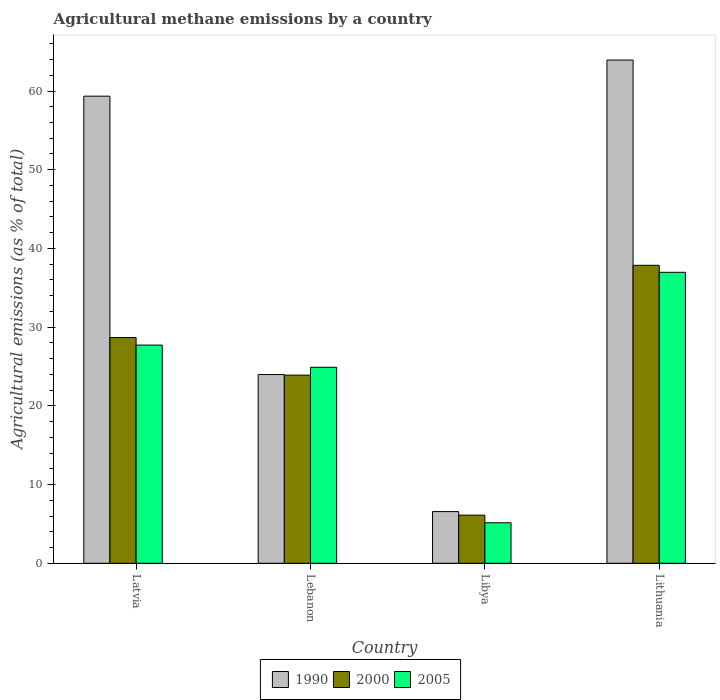How many bars are there on the 2nd tick from the left?
Give a very brief answer. 3. What is the label of the 3rd group of bars from the left?
Offer a very short reply. Libya. What is the amount of agricultural methane emitted in 1990 in Lithuania?
Your answer should be very brief. 63.93. Across all countries, what is the maximum amount of agricultural methane emitted in 2005?
Ensure brevity in your answer.  36.97. Across all countries, what is the minimum amount of agricultural methane emitted in 2000?
Offer a very short reply. 6.12. In which country was the amount of agricultural methane emitted in 2005 maximum?
Your answer should be compact. Lithuania. In which country was the amount of agricultural methane emitted in 2000 minimum?
Your response must be concise. Libya. What is the total amount of agricultural methane emitted in 2005 in the graph?
Provide a succinct answer. 94.74. What is the difference between the amount of agricultural methane emitted in 2000 in Latvia and that in Libya?
Your answer should be compact. 22.56. What is the difference between the amount of agricultural methane emitted in 2005 in Libya and the amount of agricultural methane emitted in 1990 in Lithuania?
Your answer should be compact. -58.79. What is the average amount of agricultural methane emitted in 2005 per country?
Offer a very short reply. 23.68. What is the difference between the amount of agricultural methane emitted of/in 2005 and amount of agricultural methane emitted of/in 2000 in Lebanon?
Offer a terse response. 1. What is the ratio of the amount of agricultural methane emitted in 2000 in Latvia to that in Lebanon?
Ensure brevity in your answer.  1.2. Is the amount of agricultural methane emitted in 2005 in Libya less than that in Lithuania?
Offer a terse response. Yes. What is the difference between the highest and the second highest amount of agricultural methane emitted in 2000?
Give a very brief answer. -9.18. What is the difference between the highest and the lowest amount of agricultural methane emitted in 2000?
Provide a succinct answer. 31.74. In how many countries, is the amount of agricultural methane emitted in 2005 greater than the average amount of agricultural methane emitted in 2005 taken over all countries?
Your answer should be very brief. 3. Is the sum of the amount of agricultural methane emitted in 2000 in Latvia and Lithuania greater than the maximum amount of agricultural methane emitted in 1990 across all countries?
Make the answer very short. Yes. Is it the case that in every country, the sum of the amount of agricultural methane emitted in 1990 and amount of agricultural methane emitted in 2000 is greater than the amount of agricultural methane emitted in 2005?
Provide a succinct answer. Yes. Are all the bars in the graph horizontal?
Your answer should be compact. No. How many countries are there in the graph?
Keep it short and to the point. 4. Does the graph contain any zero values?
Provide a short and direct response. No. Where does the legend appear in the graph?
Keep it short and to the point. Bottom center. How many legend labels are there?
Give a very brief answer. 3. What is the title of the graph?
Your response must be concise. Agricultural methane emissions by a country. Does "2014" appear as one of the legend labels in the graph?
Keep it short and to the point. No. What is the label or title of the X-axis?
Offer a very short reply. Country. What is the label or title of the Y-axis?
Ensure brevity in your answer.  Agricultural emissions (as % of total). What is the Agricultural emissions (as % of total) in 1990 in Latvia?
Ensure brevity in your answer.  59.34. What is the Agricultural emissions (as % of total) in 2000 in Latvia?
Provide a succinct answer. 28.68. What is the Agricultural emissions (as % of total) of 2005 in Latvia?
Offer a very short reply. 27.72. What is the Agricultural emissions (as % of total) in 1990 in Lebanon?
Offer a very short reply. 23.98. What is the Agricultural emissions (as % of total) in 2000 in Lebanon?
Your response must be concise. 23.9. What is the Agricultural emissions (as % of total) of 2005 in Lebanon?
Offer a very short reply. 24.9. What is the Agricultural emissions (as % of total) in 1990 in Libya?
Provide a succinct answer. 6.57. What is the Agricultural emissions (as % of total) of 2000 in Libya?
Provide a short and direct response. 6.12. What is the Agricultural emissions (as % of total) in 2005 in Libya?
Make the answer very short. 5.15. What is the Agricultural emissions (as % of total) in 1990 in Lithuania?
Your answer should be very brief. 63.93. What is the Agricultural emissions (as % of total) of 2000 in Lithuania?
Give a very brief answer. 37.86. What is the Agricultural emissions (as % of total) in 2005 in Lithuania?
Your response must be concise. 36.97. Across all countries, what is the maximum Agricultural emissions (as % of total) of 1990?
Give a very brief answer. 63.93. Across all countries, what is the maximum Agricultural emissions (as % of total) in 2000?
Ensure brevity in your answer.  37.86. Across all countries, what is the maximum Agricultural emissions (as % of total) of 2005?
Offer a very short reply. 36.97. Across all countries, what is the minimum Agricultural emissions (as % of total) in 1990?
Ensure brevity in your answer.  6.57. Across all countries, what is the minimum Agricultural emissions (as % of total) of 2000?
Provide a succinct answer. 6.12. Across all countries, what is the minimum Agricultural emissions (as % of total) of 2005?
Your response must be concise. 5.15. What is the total Agricultural emissions (as % of total) in 1990 in the graph?
Keep it short and to the point. 153.82. What is the total Agricultural emissions (as % of total) of 2000 in the graph?
Provide a succinct answer. 96.55. What is the total Agricultural emissions (as % of total) of 2005 in the graph?
Keep it short and to the point. 94.74. What is the difference between the Agricultural emissions (as % of total) of 1990 in Latvia and that in Lebanon?
Offer a very short reply. 35.37. What is the difference between the Agricultural emissions (as % of total) in 2000 in Latvia and that in Lebanon?
Ensure brevity in your answer.  4.78. What is the difference between the Agricultural emissions (as % of total) in 2005 in Latvia and that in Lebanon?
Your answer should be compact. 2.82. What is the difference between the Agricultural emissions (as % of total) of 1990 in Latvia and that in Libya?
Keep it short and to the point. 52.78. What is the difference between the Agricultural emissions (as % of total) in 2000 in Latvia and that in Libya?
Your response must be concise. 22.56. What is the difference between the Agricultural emissions (as % of total) of 2005 in Latvia and that in Libya?
Your response must be concise. 22.57. What is the difference between the Agricultural emissions (as % of total) of 1990 in Latvia and that in Lithuania?
Offer a very short reply. -4.59. What is the difference between the Agricultural emissions (as % of total) of 2000 in Latvia and that in Lithuania?
Offer a very short reply. -9.18. What is the difference between the Agricultural emissions (as % of total) in 2005 in Latvia and that in Lithuania?
Your response must be concise. -9.25. What is the difference between the Agricultural emissions (as % of total) of 1990 in Lebanon and that in Libya?
Provide a succinct answer. 17.41. What is the difference between the Agricultural emissions (as % of total) in 2000 in Lebanon and that in Libya?
Offer a very short reply. 17.79. What is the difference between the Agricultural emissions (as % of total) in 2005 in Lebanon and that in Libya?
Your answer should be very brief. 19.76. What is the difference between the Agricultural emissions (as % of total) in 1990 in Lebanon and that in Lithuania?
Make the answer very short. -39.96. What is the difference between the Agricultural emissions (as % of total) of 2000 in Lebanon and that in Lithuania?
Ensure brevity in your answer.  -13.95. What is the difference between the Agricultural emissions (as % of total) of 2005 in Lebanon and that in Lithuania?
Give a very brief answer. -12.07. What is the difference between the Agricultural emissions (as % of total) of 1990 in Libya and that in Lithuania?
Offer a very short reply. -57.37. What is the difference between the Agricultural emissions (as % of total) of 2000 in Libya and that in Lithuania?
Your answer should be very brief. -31.74. What is the difference between the Agricultural emissions (as % of total) of 2005 in Libya and that in Lithuania?
Make the answer very short. -31.82. What is the difference between the Agricultural emissions (as % of total) of 1990 in Latvia and the Agricultural emissions (as % of total) of 2000 in Lebanon?
Provide a short and direct response. 35.44. What is the difference between the Agricultural emissions (as % of total) of 1990 in Latvia and the Agricultural emissions (as % of total) of 2005 in Lebanon?
Your answer should be compact. 34.44. What is the difference between the Agricultural emissions (as % of total) of 2000 in Latvia and the Agricultural emissions (as % of total) of 2005 in Lebanon?
Make the answer very short. 3.78. What is the difference between the Agricultural emissions (as % of total) of 1990 in Latvia and the Agricultural emissions (as % of total) of 2000 in Libya?
Provide a succinct answer. 53.23. What is the difference between the Agricultural emissions (as % of total) in 1990 in Latvia and the Agricultural emissions (as % of total) in 2005 in Libya?
Keep it short and to the point. 54.2. What is the difference between the Agricultural emissions (as % of total) of 2000 in Latvia and the Agricultural emissions (as % of total) of 2005 in Libya?
Your answer should be compact. 23.53. What is the difference between the Agricultural emissions (as % of total) in 1990 in Latvia and the Agricultural emissions (as % of total) in 2000 in Lithuania?
Keep it short and to the point. 21.49. What is the difference between the Agricultural emissions (as % of total) of 1990 in Latvia and the Agricultural emissions (as % of total) of 2005 in Lithuania?
Offer a very short reply. 22.38. What is the difference between the Agricultural emissions (as % of total) of 2000 in Latvia and the Agricultural emissions (as % of total) of 2005 in Lithuania?
Your answer should be compact. -8.29. What is the difference between the Agricultural emissions (as % of total) in 1990 in Lebanon and the Agricultural emissions (as % of total) in 2000 in Libya?
Offer a terse response. 17.86. What is the difference between the Agricultural emissions (as % of total) of 1990 in Lebanon and the Agricultural emissions (as % of total) of 2005 in Libya?
Make the answer very short. 18.83. What is the difference between the Agricultural emissions (as % of total) in 2000 in Lebanon and the Agricultural emissions (as % of total) in 2005 in Libya?
Give a very brief answer. 18.76. What is the difference between the Agricultural emissions (as % of total) in 1990 in Lebanon and the Agricultural emissions (as % of total) in 2000 in Lithuania?
Keep it short and to the point. -13.88. What is the difference between the Agricultural emissions (as % of total) in 1990 in Lebanon and the Agricultural emissions (as % of total) in 2005 in Lithuania?
Keep it short and to the point. -12.99. What is the difference between the Agricultural emissions (as % of total) in 2000 in Lebanon and the Agricultural emissions (as % of total) in 2005 in Lithuania?
Your answer should be very brief. -13.07. What is the difference between the Agricultural emissions (as % of total) in 1990 in Libya and the Agricultural emissions (as % of total) in 2000 in Lithuania?
Your response must be concise. -31.29. What is the difference between the Agricultural emissions (as % of total) of 1990 in Libya and the Agricultural emissions (as % of total) of 2005 in Lithuania?
Your answer should be compact. -30.4. What is the difference between the Agricultural emissions (as % of total) in 2000 in Libya and the Agricultural emissions (as % of total) in 2005 in Lithuania?
Provide a succinct answer. -30.85. What is the average Agricultural emissions (as % of total) of 1990 per country?
Your answer should be very brief. 38.46. What is the average Agricultural emissions (as % of total) of 2000 per country?
Provide a succinct answer. 24.14. What is the average Agricultural emissions (as % of total) in 2005 per country?
Provide a short and direct response. 23.68. What is the difference between the Agricultural emissions (as % of total) of 1990 and Agricultural emissions (as % of total) of 2000 in Latvia?
Provide a succinct answer. 30.66. What is the difference between the Agricultural emissions (as % of total) of 1990 and Agricultural emissions (as % of total) of 2005 in Latvia?
Ensure brevity in your answer.  31.62. What is the difference between the Agricultural emissions (as % of total) in 2000 and Agricultural emissions (as % of total) in 2005 in Latvia?
Offer a terse response. 0.96. What is the difference between the Agricultural emissions (as % of total) of 1990 and Agricultural emissions (as % of total) of 2000 in Lebanon?
Ensure brevity in your answer.  0.07. What is the difference between the Agricultural emissions (as % of total) in 1990 and Agricultural emissions (as % of total) in 2005 in Lebanon?
Make the answer very short. -0.93. What is the difference between the Agricultural emissions (as % of total) of 2000 and Agricultural emissions (as % of total) of 2005 in Lebanon?
Provide a succinct answer. -1. What is the difference between the Agricultural emissions (as % of total) in 1990 and Agricultural emissions (as % of total) in 2000 in Libya?
Provide a short and direct response. 0.45. What is the difference between the Agricultural emissions (as % of total) in 1990 and Agricultural emissions (as % of total) in 2005 in Libya?
Keep it short and to the point. 1.42. What is the difference between the Agricultural emissions (as % of total) in 2000 and Agricultural emissions (as % of total) in 2005 in Libya?
Your answer should be compact. 0.97. What is the difference between the Agricultural emissions (as % of total) in 1990 and Agricultural emissions (as % of total) in 2000 in Lithuania?
Provide a short and direct response. 26.08. What is the difference between the Agricultural emissions (as % of total) of 1990 and Agricultural emissions (as % of total) of 2005 in Lithuania?
Your answer should be compact. 26.97. What is the difference between the Agricultural emissions (as % of total) in 2000 and Agricultural emissions (as % of total) in 2005 in Lithuania?
Make the answer very short. 0.89. What is the ratio of the Agricultural emissions (as % of total) in 1990 in Latvia to that in Lebanon?
Your answer should be compact. 2.48. What is the ratio of the Agricultural emissions (as % of total) in 2000 in Latvia to that in Lebanon?
Ensure brevity in your answer.  1.2. What is the ratio of the Agricultural emissions (as % of total) of 2005 in Latvia to that in Lebanon?
Provide a short and direct response. 1.11. What is the ratio of the Agricultural emissions (as % of total) in 1990 in Latvia to that in Libya?
Provide a short and direct response. 9.04. What is the ratio of the Agricultural emissions (as % of total) of 2000 in Latvia to that in Libya?
Offer a very short reply. 4.69. What is the ratio of the Agricultural emissions (as % of total) in 2005 in Latvia to that in Libya?
Offer a terse response. 5.39. What is the ratio of the Agricultural emissions (as % of total) in 1990 in Latvia to that in Lithuania?
Your answer should be compact. 0.93. What is the ratio of the Agricultural emissions (as % of total) in 2000 in Latvia to that in Lithuania?
Your answer should be very brief. 0.76. What is the ratio of the Agricultural emissions (as % of total) of 2005 in Latvia to that in Lithuania?
Your answer should be compact. 0.75. What is the ratio of the Agricultural emissions (as % of total) in 1990 in Lebanon to that in Libya?
Your answer should be compact. 3.65. What is the ratio of the Agricultural emissions (as % of total) of 2000 in Lebanon to that in Libya?
Provide a succinct answer. 3.91. What is the ratio of the Agricultural emissions (as % of total) of 2005 in Lebanon to that in Libya?
Make the answer very short. 4.84. What is the ratio of the Agricultural emissions (as % of total) of 2000 in Lebanon to that in Lithuania?
Ensure brevity in your answer.  0.63. What is the ratio of the Agricultural emissions (as % of total) of 2005 in Lebanon to that in Lithuania?
Provide a short and direct response. 0.67. What is the ratio of the Agricultural emissions (as % of total) in 1990 in Libya to that in Lithuania?
Your answer should be very brief. 0.1. What is the ratio of the Agricultural emissions (as % of total) of 2000 in Libya to that in Lithuania?
Make the answer very short. 0.16. What is the ratio of the Agricultural emissions (as % of total) in 2005 in Libya to that in Lithuania?
Ensure brevity in your answer.  0.14. What is the difference between the highest and the second highest Agricultural emissions (as % of total) in 1990?
Make the answer very short. 4.59. What is the difference between the highest and the second highest Agricultural emissions (as % of total) of 2000?
Ensure brevity in your answer.  9.18. What is the difference between the highest and the second highest Agricultural emissions (as % of total) in 2005?
Keep it short and to the point. 9.25. What is the difference between the highest and the lowest Agricultural emissions (as % of total) of 1990?
Your answer should be very brief. 57.37. What is the difference between the highest and the lowest Agricultural emissions (as % of total) in 2000?
Your answer should be compact. 31.74. What is the difference between the highest and the lowest Agricultural emissions (as % of total) of 2005?
Give a very brief answer. 31.82. 